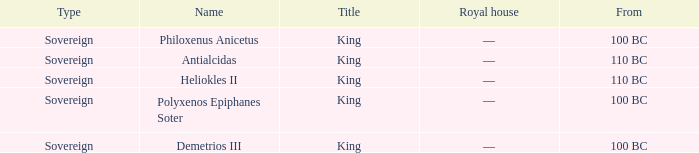When did Demetrios III begin to hold power? 100 BC. 